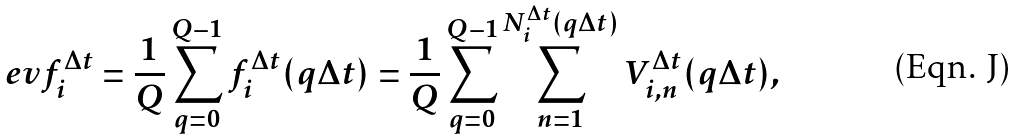<formula> <loc_0><loc_0><loc_500><loc_500>\ e v { f _ { i } ^ { \Delta t } } = \frac { 1 } { Q } \sum _ { q = 0 } ^ { Q - 1 } f _ { i } ^ { \Delta t } ( q \Delta t ) = \frac { 1 } { Q } \sum _ { q = 0 } ^ { Q - 1 } \sum _ { n = 1 } ^ { N _ { i } ^ { \Delta t } ( q \Delta t ) } V _ { i , n } ^ { \Delta t } ( q \Delta t ) ,</formula> 